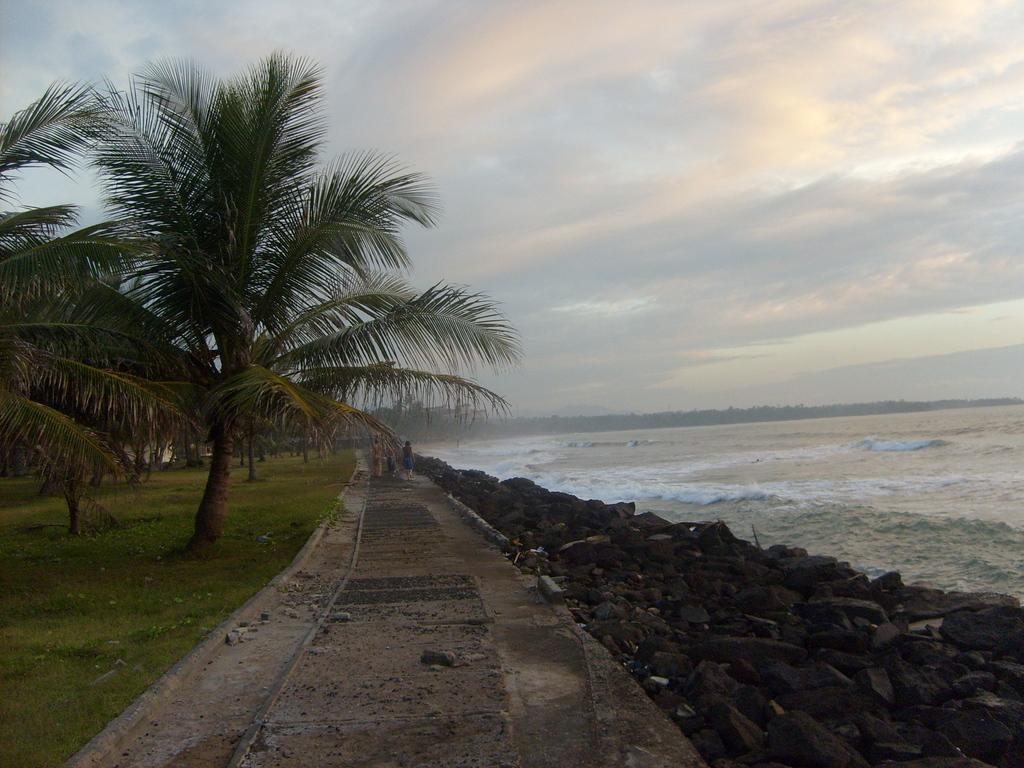Describe this image in one or two sentences. In this image we can see walkway on which there are some persons walking there are some ocean rocks, water and trees on the right side of the image and on left side of the image there are some trees and top of the image there is clear sky. 